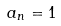Convert formula to latex. <formula><loc_0><loc_0><loc_500><loc_500>a _ { n } = 1</formula> 